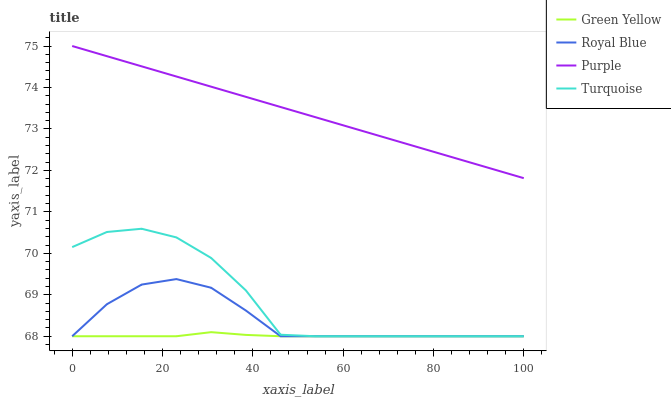Does Green Yellow have the minimum area under the curve?
Answer yes or no. Yes. Does Purple have the maximum area under the curve?
Answer yes or no. Yes. Does Royal Blue have the minimum area under the curve?
Answer yes or no. No. Does Royal Blue have the maximum area under the curve?
Answer yes or no. No. Is Purple the smoothest?
Answer yes or no. Yes. Is Turquoise the roughest?
Answer yes or no. Yes. Is Royal Blue the smoothest?
Answer yes or no. No. Is Royal Blue the roughest?
Answer yes or no. No. Does Purple have the highest value?
Answer yes or no. Yes. Does Royal Blue have the highest value?
Answer yes or no. No. Is Turquoise less than Purple?
Answer yes or no. Yes. Is Purple greater than Green Yellow?
Answer yes or no. Yes. Does Royal Blue intersect Green Yellow?
Answer yes or no. Yes. Is Royal Blue less than Green Yellow?
Answer yes or no. No. Is Royal Blue greater than Green Yellow?
Answer yes or no. No. Does Turquoise intersect Purple?
Answer yes or no. No. 